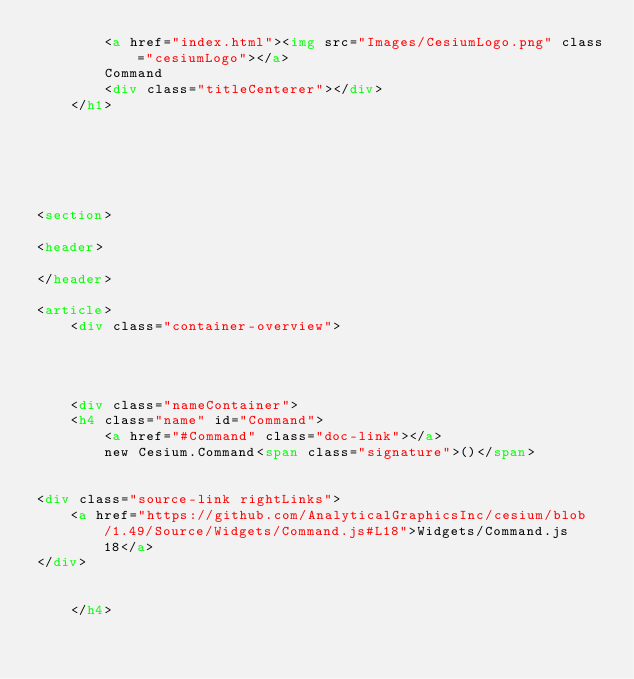Convert code to text. <code><loc_0><loc_0><loc_500><loc_500><_HTML_>        <a href="index.html"><img src="Images/CesiumLogo.png" class="cesiumLogo"></a>
        Command
        <div class="titleCenterer"></div>
    </h1>

    




<section>

<header>
    
</header>

<article>
    <div class="container-overview">
    

    
        
    <div class="nameContainer">
    <h4 class="name" id="Command">
        <a href="#Command" class="doc-link"></a>
        new Cesium.Command<span class="signature">()</span>
        

<div class="source-link rightLinks">
    <a href="https://github.com/AnalyticalGraphicsInc/cesium/blob/1.49/Source/Widgets/Command.js#L18">Widgets/Command.js 18</a>
</div>


    </h4>
</code> 